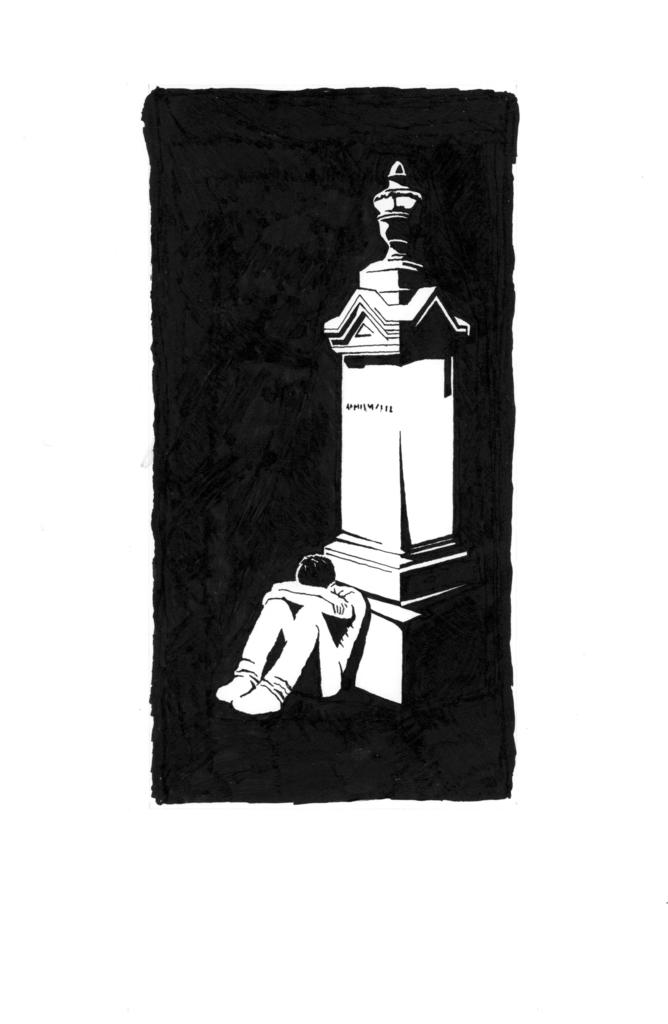What is the main subject of the image? The main subject of the image is a black object with a depiction of a pillar. Can you describe the person sitting near the depiction of the pillar? There is a person sitting near the depiction of the pillar, but no specific details about the person are provided. What is the color of the background in the image? The background of the image is white. How many dogs are sitting on the tray in the image? There is no tray or dogs present in the image. 